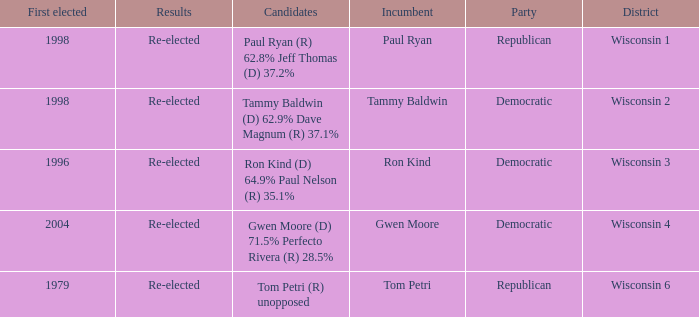What district first elected a Democratic incumbent in 1998? Wisconsin 2. 